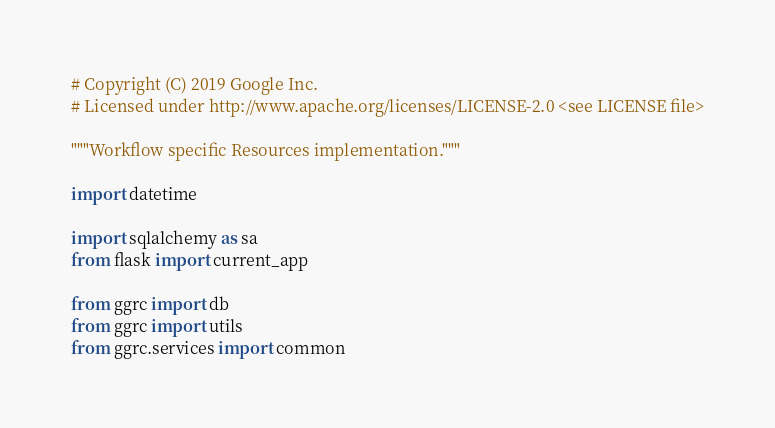<code> <loc_0><loc_0><loc_500><loc_500><_Python_># Copyright (C) 2019 Google Inc.
# Licensed under http://www.apache.org/licenses/LICENSE-2.0 <see LICENSE file>

"""Workflow specific Resources implementation."""

import datetime

import sqlalchemy as sa
from flask import current_app

from ggrc import db
from ggrc import utils
from ggrc.services import common
</code> 